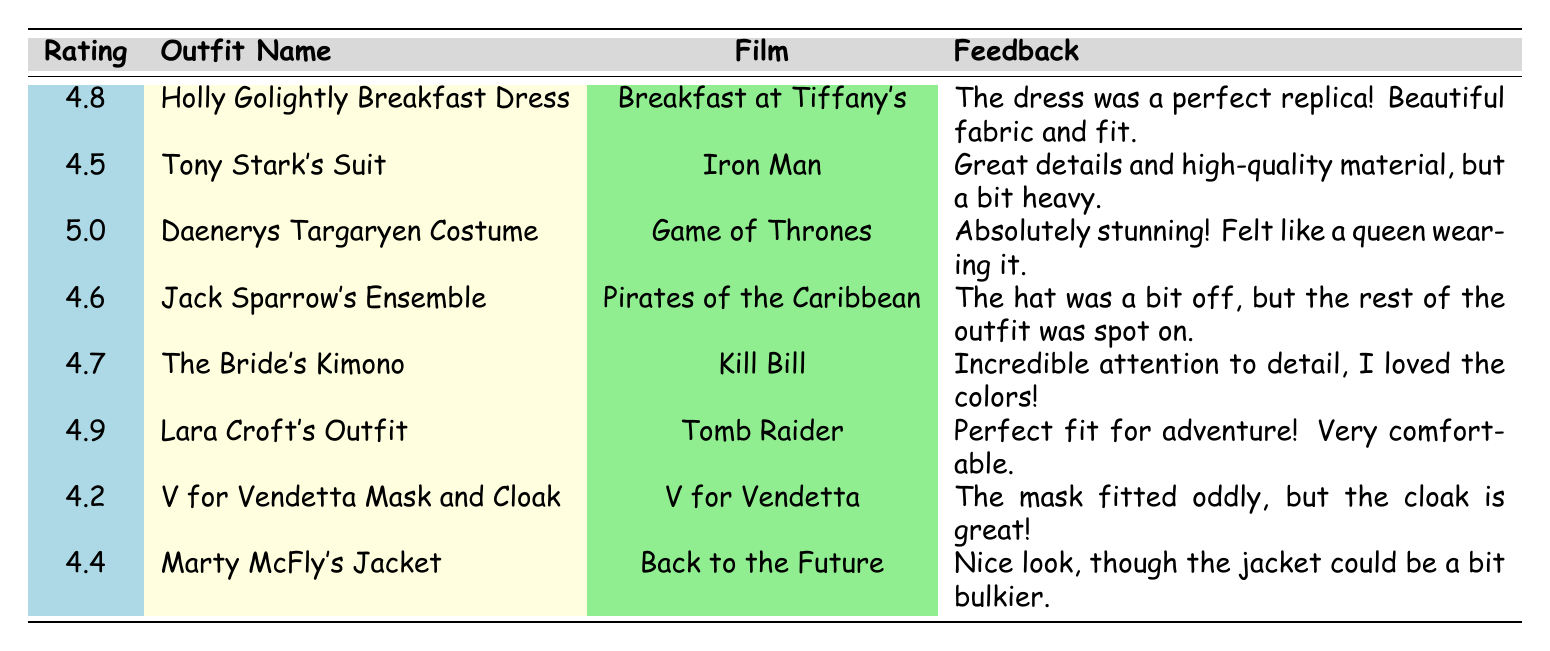What is the highest customer rating among the outfits? The highest customer rating can be found by looking at the "Rating" column. The ratings listed are 4.8, 4.5, 5.0, 4.6, 4.7, 4.9, 4.2, and 4.4. The highest value is 5.0 for Daenerys Targaryen Costume.
Answer: 5.0 Which outfit received a rating below 4.5? To find an outfit with a rating below 4.5, we can check the "Rating" column for values less than 4.5. The only outfit that fits this criterion is V for Vendetta Mask and Cloak, with a rating of 4.2.
Answer: V for Vendetta Mask and Cloak What is the average customer rating of all the outfits? First, we sum the ratings: (4.8 + 4.5 + 5.0 + 4.6 + 4.7 + 4.9 + 4.2 + 4.4) = 38.1. There are 8 outfits, so we divide the total by 8: 38.1 / 8 = 4.7625. Rounding this gives an average rating of approximately 4.76.
Answer: 4.76 Did Sarah Johnson rate her outfit higher than 4.5? Sarah Johnson's outfit, Daenerys Targaryen Costume, has a customer rating of 5.0. Since 5.0 is greater than 4.5, the answer is yes.
Answer: Yes Which outfit had the most positive feedback? To identify the most positive feedback, we can look for comments that express strong satisfaction. The feedback for Daenerys Targaryen Costume is "Absolutely stunning! Felt like a queen wearing it," indicating the highest level of praise.
Answer: Daenerys Targaryen Costume 